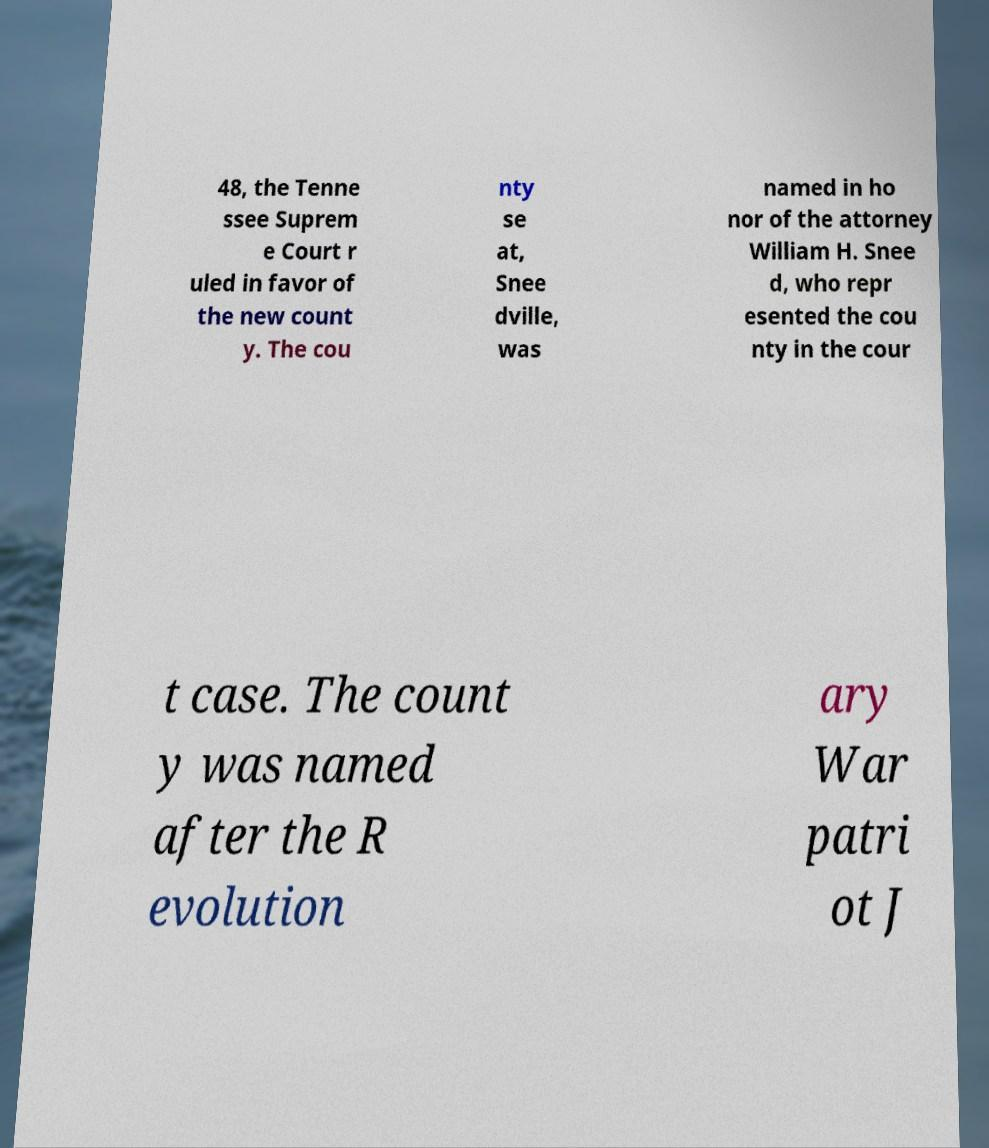Please read and relay the text visible in this image. What does it say? 48, the Tenne ssee Suprem e Court r uled in favor of the new count y. The cou nty se at, Snee dville, was named in ho nor of the attorney William H. Snee d, who repr esented the cou nty in the cour t case. The count y was named after the R evolution ary War patri ot J 